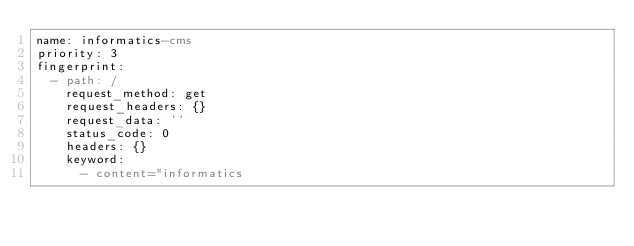<code> <loc_0><loc_0><loc_500><loc_500><_YAML_>name: informatics-cms
priority: 3
fingerprint:
  - path: /
    request_method: get
    request_headers: {}
    request_data: ''
    status_code: 0
    headers: {}
    keyword:
      - content="informatics
</code> 